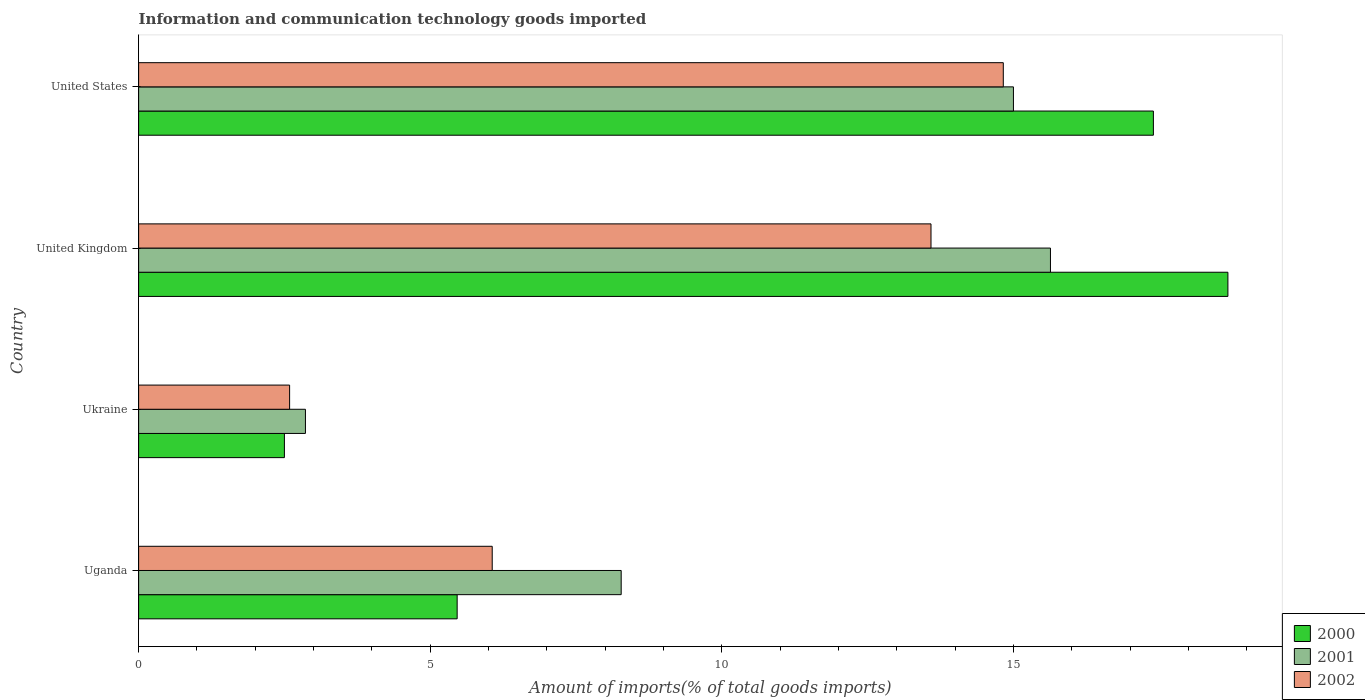How many different coloured bars are there?
Provide a succinct answer. 3. How many groups of bars are there?
Provide a short and direct response. 4. Are the number of bars per tick equal to the number of legend labels?
Your answer should be compact. Yes. Are the number of bars on each tick of the Y-axis equal?
Your answer should be very brief. Yes. How many bars are there on the 4th tick from the top?
Offer a very short reply. 3. What is the label of the 1st group of bars from the top?
Provide a short and direct response. United States. In how many cases, is the number of bars for a given country not equal to the number of legend labels?
Provide a short and direct response. 0. What is the amount of goods imported in 2001 in United States?
Make the answer very short. 15. Across all countries, what is the maximum amount of goods imported in 2002?
Give a very brief answer. 14.82. Across all countries, what is the minimum amount of goods imported in 2001?
Give a very brief answer. 2.86. In which country was the amount of goods imported in 2001 minimum?
Offer a terse response. Ukraine. What is the total amount of goods imported in 2002 in the graph?
Give a very brief answer. 37.06. What is the difference between the amount of goods imported in 2001 in Uganda and that in United States?
Provide a short and direct response. -6.72. What is the difference between the amount of goods imported in 2001 in Ukraine and the amount of goods imported in 2000 in United States?
Provide a short and direct response. -14.54. What is the average amount of goods imported in 2002 per country?
Provide a short and direct response. 9.26. What is the difference between the amount of goods imported in 2001 and amount of goods imported in 2000 in Uganda?
Your response must be concise. 2.81. In how many countries, is the amount of goods imported in 2002 greater than 12 %?
Your answer should be very brief. 2. What is the ratio of the amount of goods imported in 2002 in Uganda to that in Ukraine?
Your answer should be very brief. 2.34. Is the amount of goods imported in 2002 in Uganda less than that in United States?
Your answer should be very brief. Yes. What is the difference between the highest and the second highest amount of goods imported in 2000?
Provide a succinct answer. 1.28. What is the difference between the highest and the lowest amount of goods imported in 2002?
Your answer should be compact. 12.23. In how many countries, is the amount of goods imported in 2001 greater than the average amount of goods imported in 2001 taken over all countries?
Give a very brief answer. 2. Is the sum of the amount of goods imported in 2000 in Uganda and United Kingdom greater than the maximum amount of goods imported in 2001 across all countries?
Your answer should be compact. Yes. What does the 3rd bar from the top in Uganda represents?
Provide a succinct answer. 2000. Is it the case that in every country, the sum of the amount of goods imported in 2000 and amount of goods imported in 2001 is greater than the amount of goods imported in 2002?
Offer a very short reply. Yes. Are all the bars in the graph horizontal?
Your response must be concise. Yes. What is the difference between two consecutive major ticks on the X-axis?
Your answer should be very brief. 5. Does the graph contain grids?
Give a very brief answer. No. Where does the legend appear in the graph?
Offer a very short reply. Bottom right. How are the legend labels stacked?
Your answer should be very brief. Vertical. What is the title of the graph?
Make the answer very short. Information and communication technology goods imported. Does "2015" appear as one of the legend labels in the graph?
Ensure brevity in your answer.  No. What is the label or title of the X-axis?
Give a very brief answer. Amount of imports(% of total goods imports). What is the Amount of imports(% of total goods imports) of 2000 in Uganda?
Keep it short and to the point. 5.46. What is the Amount of imports(% of total goods imports) of 2001 in Uganda?
Your answer should be compact. 8.27. What is the Amount of imports(% of total goods imports) in 2002 in Uganda?
Offer a terse response. 6.06. What is the Amount of imports(% of total goods imports) in 2000 in Ukraine?
Offer a very short reply. 2.5. What is the Amount of imports(% of total goods imports) in 2001 in Ukraine?
Provide a short and direct response. 2.86. What is the Amount of imports(% of total goods imports) of 2002 in Ukraine?
Keep it short and to the point. 2.59. What is the Amount of imports(% of total goods imports) in 2000 in United Kingdom?
Keep it short and to the point. 18.67. What is the Amount of imports(% of total goods imports) in 2001 in United Kingdom?
Offer a very short reply. 15.63. What is the Amount of imports(% of total goods imports) of 2002 in United Kingdom?
Your response must be concise. 13.58. What is the Amount of imports(% of total goods imports) of 2000 in United States?
Provide a succinct answer. 17.4. What is the Amount of imports(% of total goods imports) of 2001 in United States?
Provide a short and direct response. 15. What is the Amount of imports(% of total goods imports) of 2002 in United States?
Ensure brevity in your answer.  14.82. Across all countries, what is the maximum Amount of imports(% of total goods imports) in 2000?
Offer a terse response. 18.67. Across all countries, what is the maximum Amount of imports(% of total goods imports) in 2001?
Provide a short and direct response. 15.63. Across all countries, what is the maximum Amount of imports(% of total goods imports) in 2002?
Provide a succinct answer. 14.82. Across all countries, what is the minimum Amount of imports(% of total goods imports) of 2000?
Provide a short and direct response. 2.5. Across all countries, what is the minimum Amount of imports(% of total goods imports) in 2001?
Provide a short and direct response. 2.86. Across all countries, what is the minimum Amount of imports(% of total goods imports) in 2002?
Provide a short and direct response. 2.59. What is the total Amount of imports(% of total goods imports) of 2000 in the graph?
Ensure brevity in your answer.  44.03. What is the total Amount of imports(% of total goods imports) in 2001 in the graph?
Make the answer very short. 41.76. What is the total Amount of imports(% of total goods imports) of 2002 in the graph?
Your answer should be compact. 37.06. What is the difference between the Amount of imports(% of total goods imports) of 2000 in Uganda and that in Ukraine?
Ensure brevity in your answer.  2.96. What is the difference between the Amount of imports(% of total goods imports) in 2001 in Uganda and that in Ukraine?
Give a very brief answer. 5.41. What is the difference between the Amount of imports(% of total goods imports) in 2002 in Uganda and that in Ukraine?
Provide a succinct answer. 3.47. What is the difference between the Amount of imports(% of total goods imports) of 2000 in Uganda and that in United Kingdom?
Make the answer very short. -13.21. What is the difference between the Amount of imports(% of total goods imports) of 2001 in Uganda and that in United Kingdom?
Make the answer very short. -7.36. What is the difference between the Amount of imports(% of total goods imports) in 2002 in Uganda and that in United Kingdom?
Make the answer very short. -7.52. What is the difference between the Amount of imports(% of total goods imports) of 2000 in Uganda and that in United States?
Provide a succinct answer. -11.94. What is the difference between the Amount of imports(% of total goods imports) in 2001 in Uganda and that in United States?
Your answer should be compact. -6.72. What is the difference between the Amount of imports(% of total goods imports) of 2002 in Uganda and that in United States?
Provide a succinct answer. -8.76. What is the difference between the Amount of imports(% of total goods imports) in 2000 in Ukraine and that in United Kingdom?
Provide a short and direct response. -16.17. What is the difference between the Amount of imports(% of total goods imports) of 2001 in Ukraine and that in United Kingdom?
Make the answer very short. -12.77. What is the difference between the Amount of imports(% of total goods imports) of 2002 in Ukraine and that in United Kingdom?
Your response must be concise. -11. What is the difference between the Amount of imports(% of total goods imports) in 2000 in Ukraine and that in United States?
Ensure brevity in your answer.  -14.9. What is the difference between the Amount of imports(% of total goods imports) in 2001 in Ukraine and that in United States?
Your answer should be very brief. -12.14. What is the difference between the Amount of imports(% of total goods imports) in 2002 in Ukraine and that in United States?
Ensure brevity in your answer.  -12.23. What is the difference between the Amount of imports(% of total goods imports) in 2000 in United Kingdom and that in United States?
Offer a very short reply. 1.28. What is the difference between the Amount of imports(% of total goods imports) in 2001 in United Kingdom and that in United States?
Your response must be concise. 0.63. What is the difference between the Amount of imports(% of total goods imports) in 2002 in United Kingdom and that in United States?
Your answer should be compact. -1.24. What is the difference between the Amount of imports(% of total goods imports) in 2000 in Uganda and the Amount of imports(% of total goods imports) in 2001 in Ukraine?
Make the answer very short. 2.6. What is the difference between the Amount of imports(% of total goods imports) in 2000 in Uganda and the Amount of imports(% of total goods imports) in 2002 in Ukraine?
Provide a succinct answer. 2.87. What is the difference between the Amount of imports(% of total goods imports) of 2001 in Uganda and the Amount of imports(% of total goods imports) of 2002 in Ukraine?
Your response must be concise. 5.68. What is the difference between the Amount of imports(% of total goods imports) in 2000 in Uganda and the Amount of imports(% of total goods imports) in 2001 in United Kingdom?
Give a very brief answer. -10.17. What is the difference between the Amount of imports(% of total goods imports) of 2000 in Uganda and the Amount of imports(% of total goods imports) of 2002 in United Kingdom?
Give a very brief answer. -8.12. What is the difference between the Amount of imports(% of total goods imports) in 2001 in Uganda and the Amount of imports(% of total goods imports) in 2002 in United Kingdom?
Offer a terse response. -5.31. What is the difference between the Amount of imports(% of total goods imports) in 2000 in Uganda and the Amount of imports(% of total goods imports) in 2001 in United States?
Your answer should be very brief. -9.54. What is the difference between the Amount of imports(% of total goods imports) of 2000 in Uganda and the Amount of imports(% of total goods imports) of 2002 in United States?
Keep it short and to the point. -9.36. What is the difference between the Amount of imports(% of total goods imports) in 2001 in Uganda and the Amount of imports(% of total goods imports) in 2002 in United States?
Offer a very short reply. -6.55. What is the difference between the Amount of imports(% of total goods imports) in 2000 in Ukraine and the Amount of imports(% of total goods imports) in 2001 in United Kingdom?
Your answer should be compact. -13.13. What is the difference between the Amount of imports(% of total goods imports) in 2000 in Ukraine and the Amount of imports(% of total goods imports) in 2002 in United Kingdom?
Provide a succinct answer. -11.08. What is the difference between the Amount of imports(% of total goods imports) of 2001 in Ukraine and the Amount of imports(% of total goods imports) of 2002 in United Kingdom?
Your answer should be compact. -10.72. What is the difference between the Amount of imports(% of total goods imports) in 2000 in Ukraine and the Amount of imports(% of total goods imports) in 2001 in United States?
Your answer should be very brief. -12.5. What is the difference between the Amount of imports(% of total goods imports) in 2000 in Ukraine and the Amount of imports(% of total goods imports) in 2002 in United States?
Your answer should be compact. -12.32. What is the difference between the Amount of imports(% of total goods imports) of 2001 in Ukraine and the Amount of imports(% of total goods imports) of 2002 in United States?
Ensure brevity in your answer.  -11.96. What is the difference between the Amount of imports(% of total goods imports) of 2000 in United Kingdom and the Amount of imports(% of total goods imports) of 2001 in United States?
Keep it short and to the point. 3.68. What is the difference between the Amount of imports(% of total goods imports) in 2000 in United Kingdom and the Amount of imports(% of total goods imports) in 2002 in United States?
Ensure brevity in your answer.  3.85. What is the difference between the Amount of imports(% of total goods imports) of 2001 in United Kingdom and the Amount of imports(% of total goods imports) of 2002 in United States?
Provide a succinct answer. 0.81. What is the average Amount of imports(% of total goods imports) in 2000 per country?
Give a very brief answer. 11.01. What is the average Amount of imports(% of total goods imports) of 2001 per country?
Give a very brief answer. 10.44. What is the average Amount of imports(% of total goods imports) of 2002 per country?
Give a very brief answer. 9.26. What is the difference between the Amount of imports(% of total goods imports) of 2000 and Amount of imports(% of total goods imports) of 2001 in Uganda?
Ensure brevity in your answer.  -2.81. What is the difference between the Amount of imports(% of total goods imports) of 2000 and Amount of imports(% of total goods imports) of 2002 in Uganda?
Keep it short and to the point. -0.6. What is the difference between the Amount of imports(% of total goods imports) in 2001 and Amount of imports(% of total goods imports) in 2002 in Uganda?
Make the answer very short. 2.21. What is the difference between the Amount of imports(% of total goods imports) in 2000 and Amount of imports(% of total goods imports) in 2001 in Ukraine?
Make the answer very short. -0.36. What is the difference between the Amount of imports(% of total goods imports) of 2000 and Amount of imports(% of total goods imports) of 2002 in Ukraine?
Ensure brevity in your answer.  -0.09. What is the difference between the Amount of imports(% of total goods imports) in 2001 and Amount of imports(% of total goods imports) in 2002 in Ukraine?
Keep it short and to the point. 0.27. What is the difference between the Amount of imports(% of total goods imports) of 2000 and Amount of imports(% of total goods imports) of 2001 in United Kingdom?
Ensure brevity in your answer.  3.04. What is the difference between the Amount of imports(% of total goods imports) in 2000 and Amount of imports(% of total goods imports) in 2002 in United Kingdom?
Offer a terse response. 5.09. What is the difference between the Amount of imports(% of total goods imports) in 2001 and Amount of imports(% of total goods imports) in 2002 in United Kingdom?
Your answer should be very brief. 2.05. What is the difference between the Amount of imports(% of total goods imports) of 2000 and Amount of imports(% of total goods imports) of 2001 in United States?
Offer a very short reply. 2.4. What is the difference between the Amount of imports(% of total goods imports) of 2000 and Amount of imports(% of total goods imports) of 2002 in United States?
Give a very brief answer. 2.57. What is the difference between the Amount of imports(% of total goods imports) of 2001 and Amount of imports(% of total goods imports) of 2002 in United States?
Offer a terse response. 0.17. What is the ratio of the Amount of imports(% of total goods imports) of 2000 in Uganda to that in Ukraine?
Ensure brevity in your answer.  2.19. What is the ratio of the Amount of imports(% of total goods imports) in 2001 in Uganda to that in Ukraine?
Provide a succinct answer. 2.89. What is the ratio of the Amount of imports(% of total goods imports) of 2002 in Uganda to that in Ukraine?
Offer a very short reply. 2.34. What is the ratio of the Amount of imports(% of total goods imports) of 2000 in Uganda to that in United Kingdom?
Your answer should be compact. 0.29. What is the ratio of the Amount of imports(% of total goods imports) of 2001 in Uganda to that in United Kingdom?
Make the answer very short. 0.53. What is the ratio of the Amount of imports(% of total goods imports) in 2002 in Uganda to that in United Kingdom?
Your answer should be very brief. 0.45. What is the ratio of the Amount of imports(% of total goods imports) in 2000 in Uganda to that in United States?
Offer a very short reply. 0.31. What is the ratio of the Amount of imports(% of total goods imports) of 2001 in Uganda to that in United States?
Your answer should be very brief. 0.55. What is the ratio of the Amount of imports(% of total goods imports) of 2002 in Uganda to that in United States?
Offer a terse response. 0.41. What is the ratio of the Amount of imports(% of total goods imports) in 2000 in Ukraine to that in United Kingdom?
Keep it short and to the point. 0.13. What is the ratio of the Amount of imports(% of total goods imports) in 2001 in Ukraine to that in United Kingdom?
Provide a succinct answer. 0.18. What is the ratio of the Amount of imports(% of total goods imports) of 2002 in Ukraine to that in United Kingdom?
Your answer should be very brief. 0.19. What is the ratio of the Amount of imports(% of total goods imports) of 2000 in Ukraine to that in United States?
Give a very brief answer. 0.14. What is the ratio of the Amount of imports(% of total goods imports) of 2001 in Ukraine to that in United States?
Keep it short and to the point. 0.19. What is the ratio of the Amount of imports(% of total goods imports) in 2002 in Ukraine to that in United States?
Offer a terse response. 0.17. What is the ratio of the Amount of imports(% of total goods imports) of 2000 in United Kingdom to that in United States?
Ensure brevity in your answer.  1.07. What is the ratio of the Amount of imports(% of total goods imports) in 2001 in United Kingdom to that in United States?
Make the answer very short. 1.04. What is the ratio of the Amount of imports(% of total goods imports) of 2002 in United Kingdom to that in United States?
Your answer should be compact. 0.92. What is the difference between the highest and the second highest Amount of imports(% of total goods imports) in 2000?
Provide a short and direct response. 1.28. What is the difference between the highest and the second highest Amount of imports(% of total goods imports) of 2001?
Provide a succinct answer. 0.63. What is the difference between the highest and the second highest Amount of imports(% of total goods imports) in 2002?
Offer a very short reply. 1.24. What is the difference between the highest and the lowest Amount of imports(% of total goods imports) of 2000?
Offer a very short reply. 16.17. What is the difference between the highest and the lowest Amount of imports(% of total goods imports) of 2001?
Ensure brevity in your answer.  12.77. What is the difference between the highest and the lowest Amount of imports(% of total goods imports) of 2002?
Your answer should be compact. 12.23. 